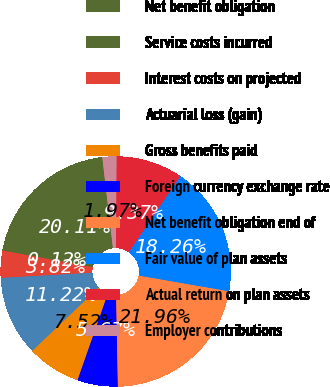<chart> <loc_0><loc_0><loc_500><loc_500><pie_chart><fcel>Net benefit obligation<fcel>Service costs incurred<fcel>Interest costs on projected<fcel>Actuarial loss (gain)<fcel>Gross benefits paid<fcel>Foreign currency exchange rate<fcel>Net benefit obligation end of<fcel>Fair value of plan assets<fcel>Actual return on plan assets<fcel>Employer contributions<nl><fcel>20.11%<fcel>0.12%<fcel>3.82%<fcel>11.22%<fcel>7.52%<fcel>5.67%<fcel>21.96%<fcel>18.26%<fcel>9.37%<fcel>1.97%<nl></chart> 